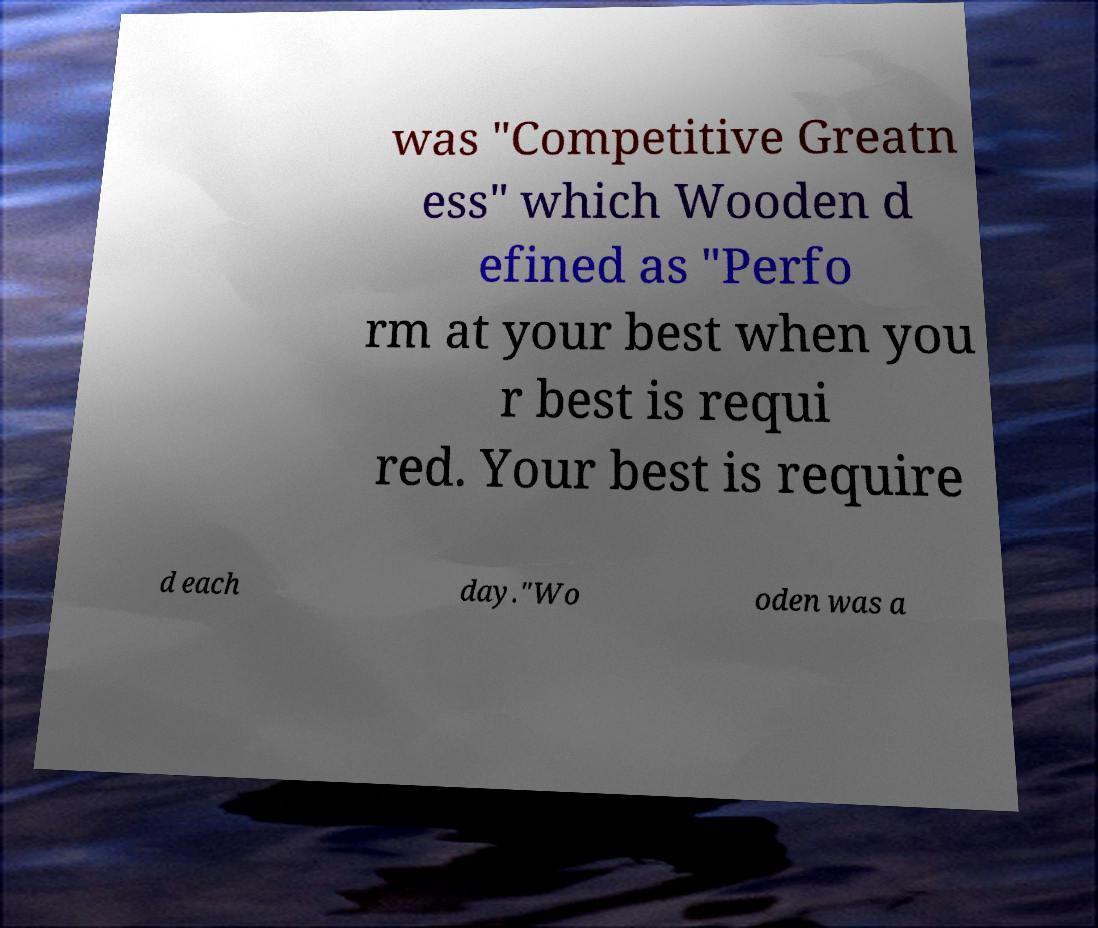For documentation purposes, I need the text within this image transcribed. Could you provide that? was "Competitive Greatn ess" which Wooden d efined as "Perfo rm at your best when you r best is requi red. Your best is require d each day."Wo oden was a 